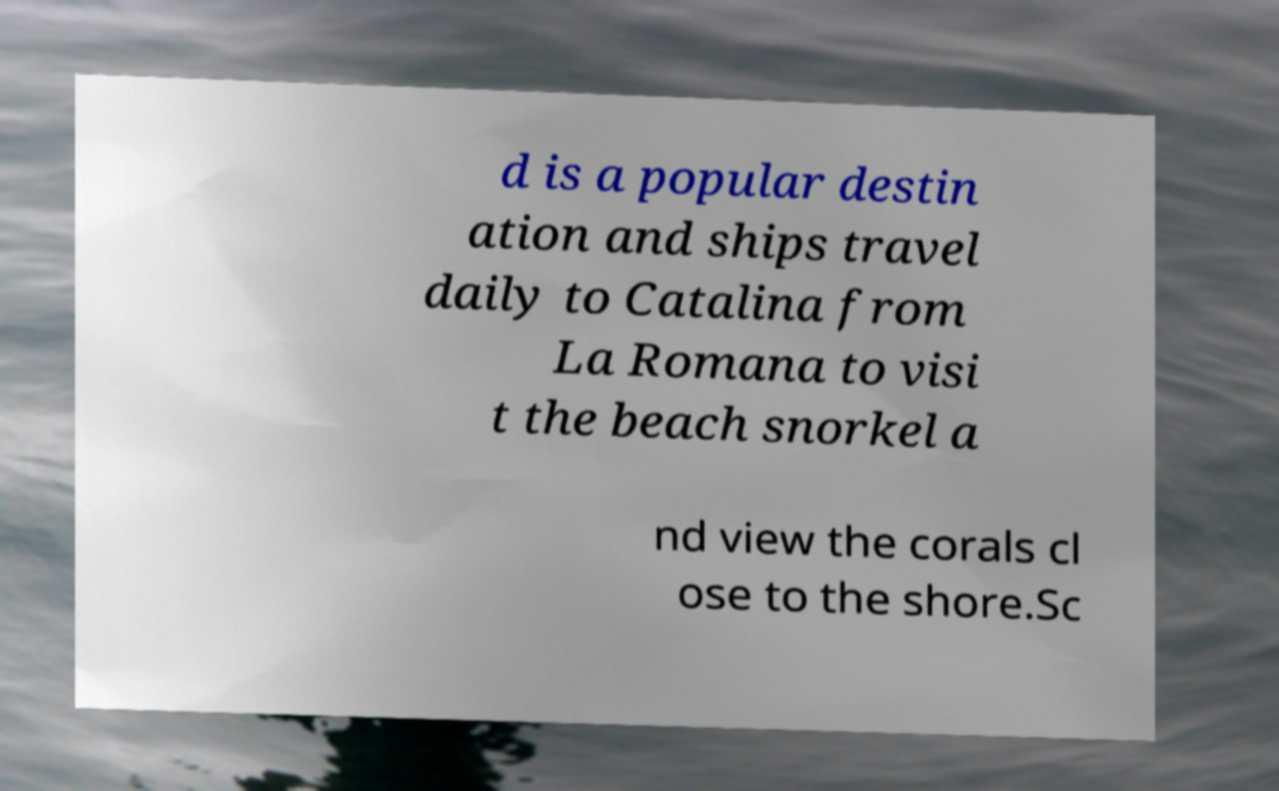Could you assist in decoding the text presented in this image and type it out clearly? d is a popular destin ation and ships travel daily to Catalina from La Romana to visi t the beach snorkel a nd view the corals cl ose to the shore.Sc 